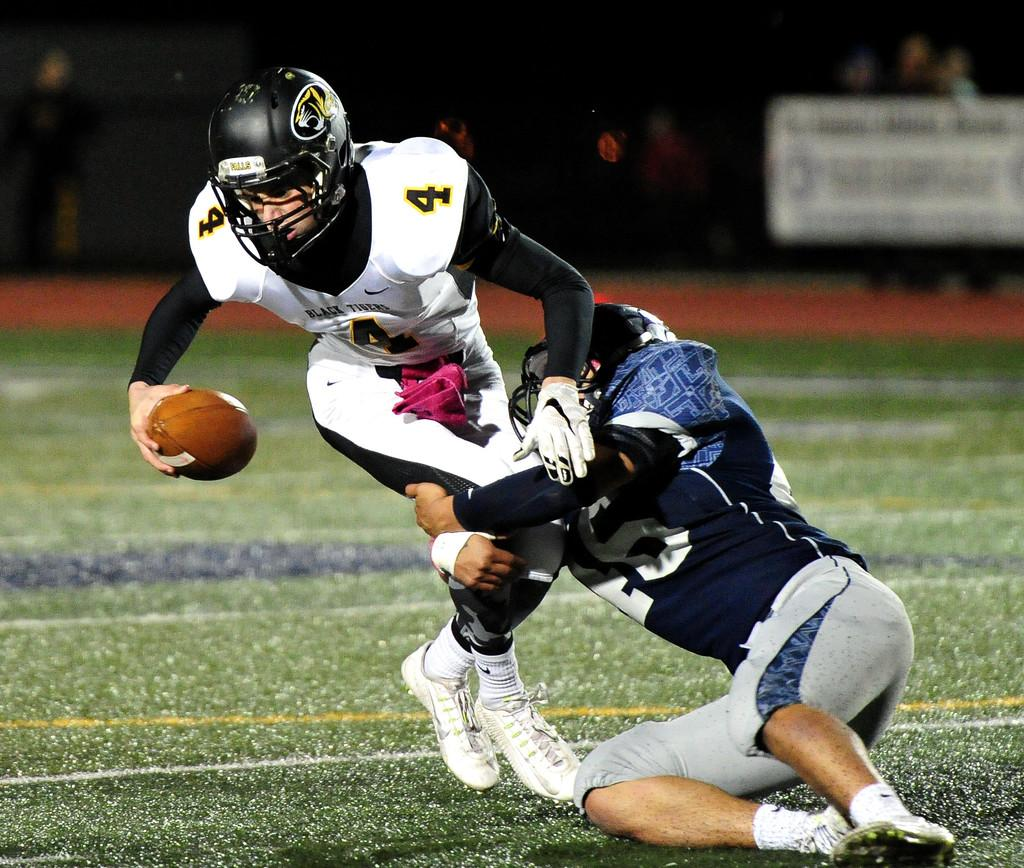How many people are involved in the activity shown in the image? There are two people in the image. What are the two people doing in the image? The two people are playing with a rugby ball. Where is the rugby ball located in the image? The rugby ball is on the ground. What can be observed about the people in the background of the image? The people in the background are spectating the two people playing with the rugby ball. What type of produce can be seen in the image? There is no produce present in the image; it features two people playing with a rugby ball. Is the image taken in a downtown area? The provided facts do not mention the location or setting of the image, so it cannot be determined if it was taken in a downtown area. 